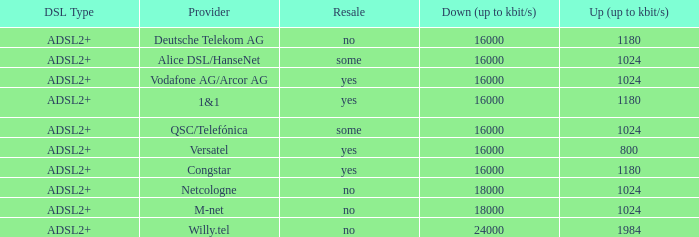What is download bandwith where the provider is deutsche telekom ag? 16000.0. 